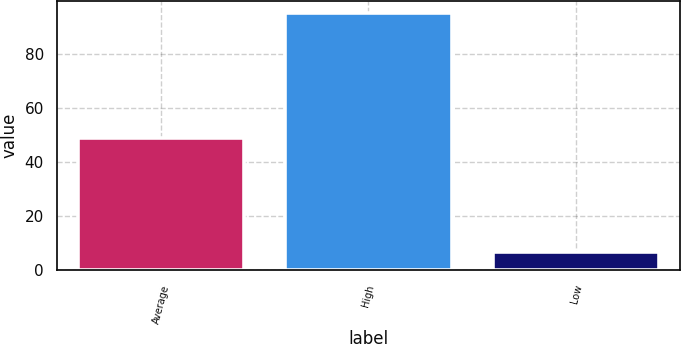Convert chart to OTSL. <chart><loc_0><loc_0><loc_500><loc_500><bar_chart><fcel>Average<fcel>High<fcel>Low<nl><fcel>49<fcel>95<fcel>7<nl></chart> 